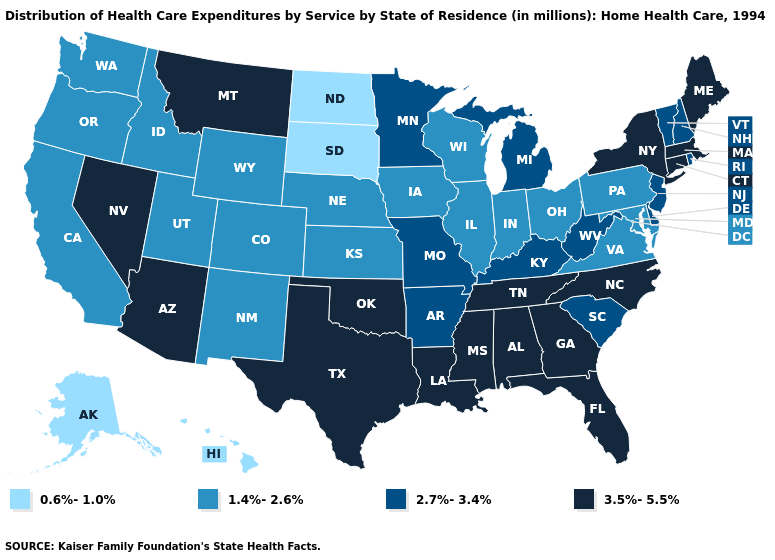Which states have the highest value in the USA?
Short answer required. Alabama, Arizona, Connecticut, Florida, Georgia, Louisiana, Maine, Massachusetts, Mississippi, Montana, Nevada, New York, North Carolina, Oklahoma, Tennessee, Texas. Does Ohio have a higher value than Alaska?
Keep it brief. Yes. What is the value of South Carolina?
Answer briefly. 2.7%-3.4%. Does South Dakota have the lowest value in the MidWest?
Give a very brief answer. Yes. What is the value of North Dakota?
Short answer required. 0.6%-1.0%. Name the states that have a value in the range 1.4%-2.6%?
Write a very short answer. California, Colorado, Idaho, Illinois, Indiana, Iowa, Kansas, Maryland, Nebraska, New Mexico, Ohio, Oregon, Pennsylvania, Utah, Virginia, Washington, Wisconsin, Wyoming. What is the value of Georgia?
Give a very brief answer. 3.5%-5.5%. Does Alaska have the lowest value in the USA?
Keep it brief. Yes. Does Michigan have the highest value in the MidWest?
Be succinct. Yes. Does California have a higher value than Hawaii?
Concise answer only. Yes. What is the value of Maine?
Keep it brief. 3.5%-5.5%. Does North Dakota have the highest value in the MidWest?
Answer briefly. No. What is the value of Arizona?
Short answer required. 3.5%-5.5%. What is the value of Wyoming?
Quick response, please. 1.4%-2.6%. What is the value of Nevada?
Short answer required. 3.5%-5.5%. 